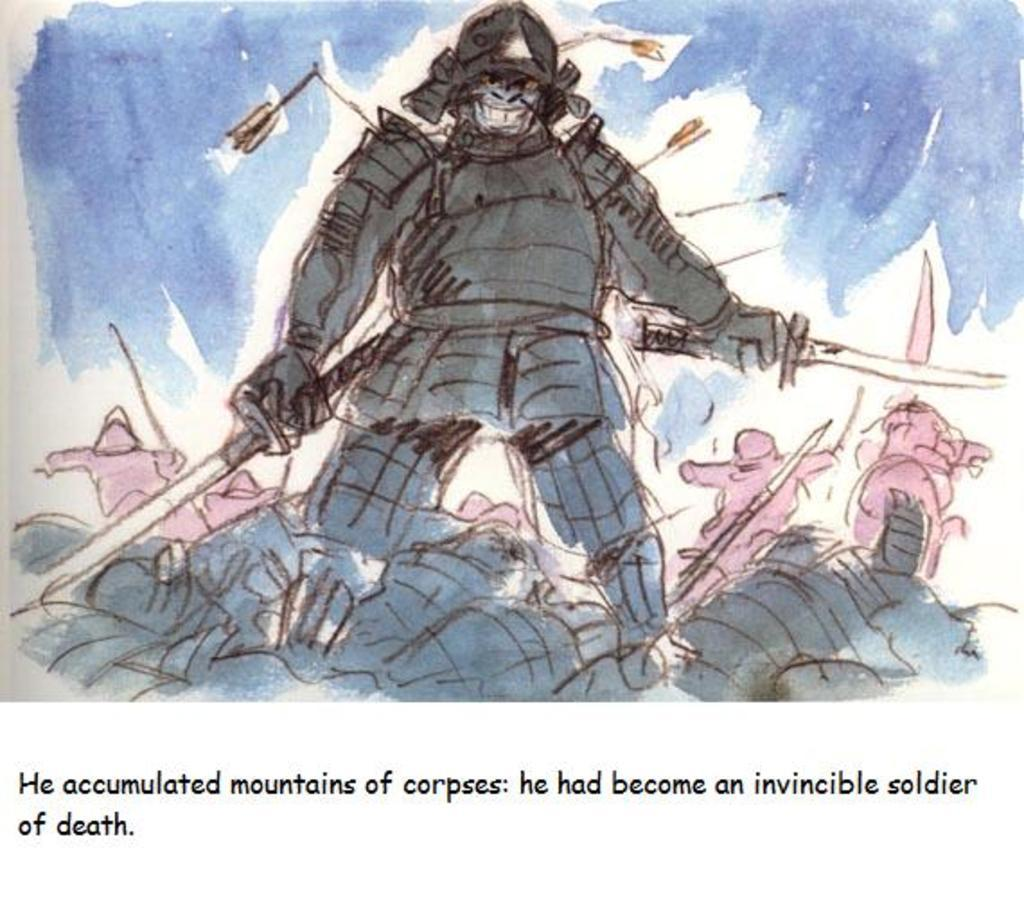What is the main subject in the middle of the image? There is a soldier in the middle of the image. Where is the queen sitting in the image? There is no queen present in the image; it only features a soldier. What type of basket is visible in the image? There is no basket present in the image. 